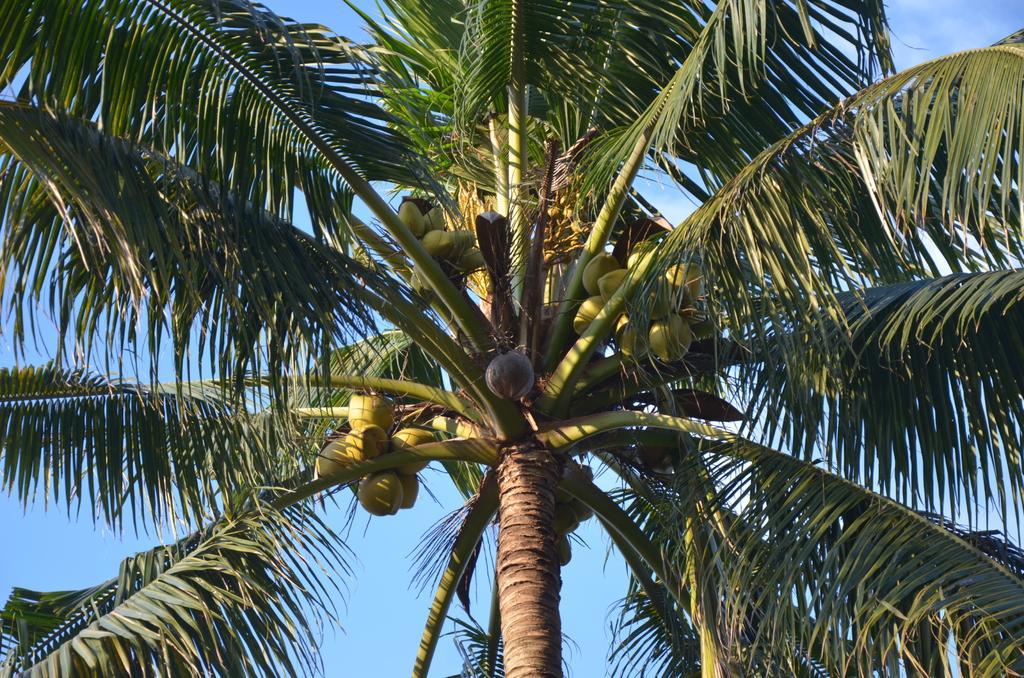Describe this image in one or two sentences. In this image we can see a group of coconuts and leaves on branches of a tree. In the background, we can see the sky. 